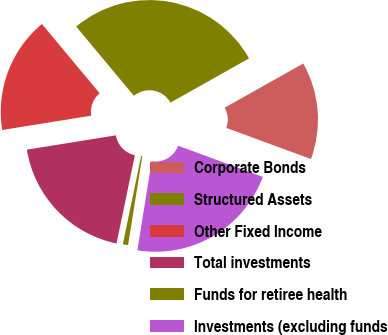<chart> <loc_0><loc_0><loc_500><loc_500><pie_chart><fcel>Corporate Bonds<fcel>Structured Assets<fcel>Other Fixed Income<fcel>Total investments<fcel>Funds for retiree health<fcel>Investments (excluding funds<nl><fcel>13.76%<fcel>27.9%<fcel>16.48%<fcel>19.2%<fcel>0.74%<fcel>21.91%<nl></chart> 